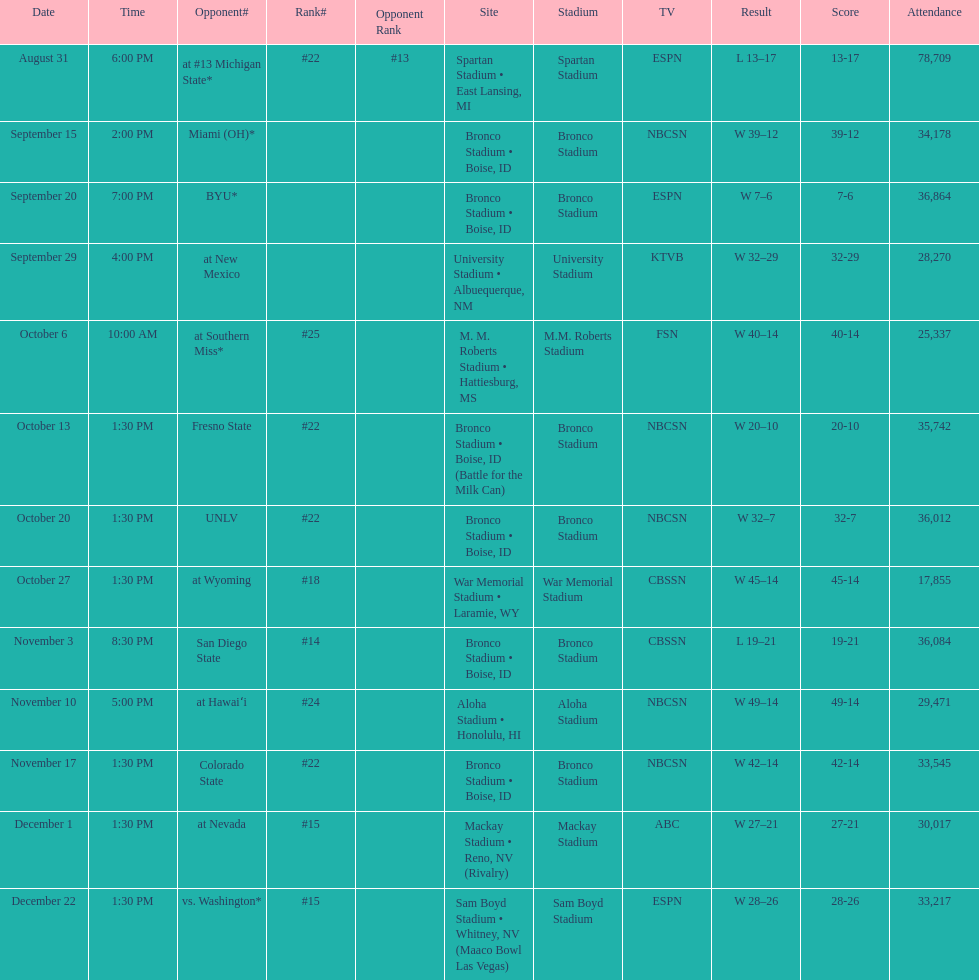On september 29th, did the broncos secure a victory with a margin of fewer than 5 points? Yes. 